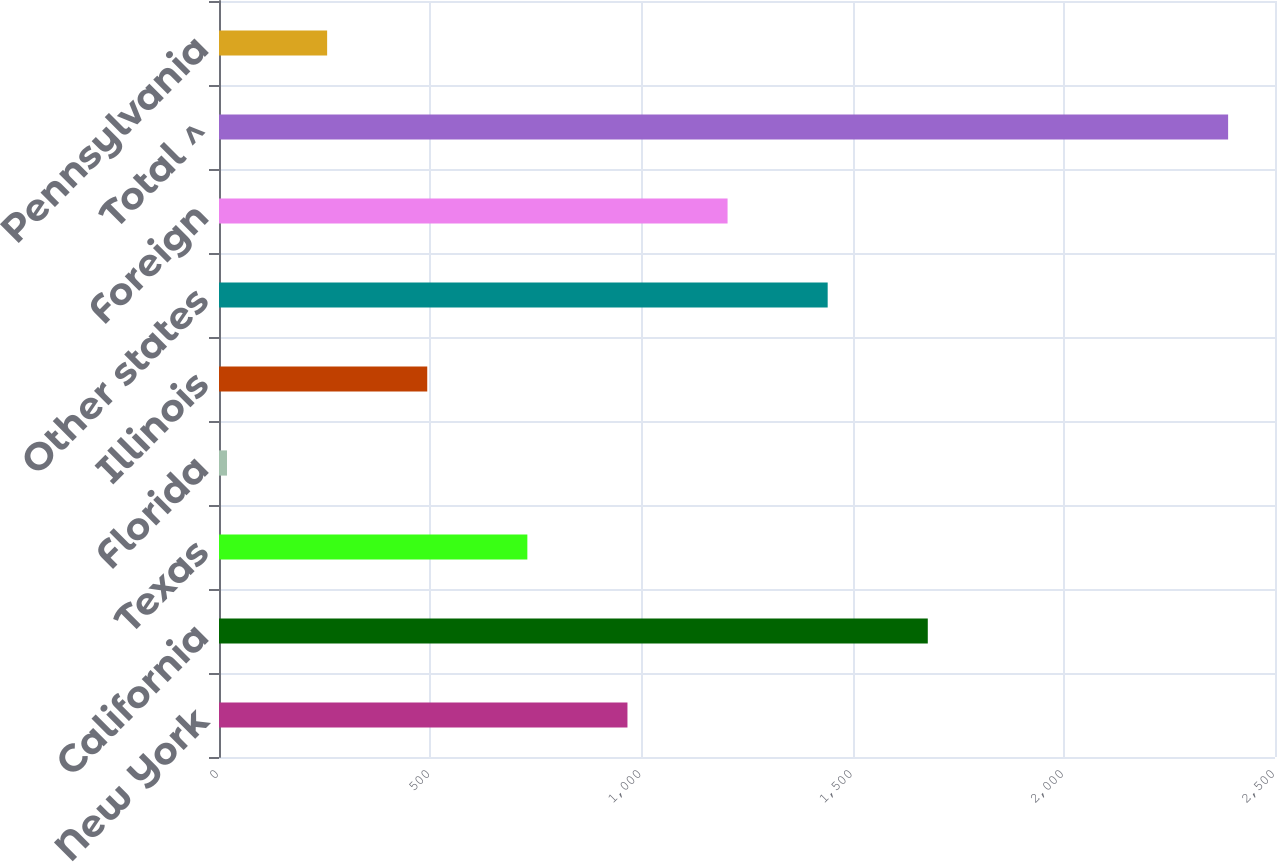Convert chart. <chart><loc_0><loc_0><loc_500><loc_500><bar_chart><fcel>New York<fcel>California<fcel>Texas<fcel>Florida<fcel>Illinois<fcel>Other states<fcel>Foreign<fcel>Total ^<fcel>Pennsylvania<nl><fcel>967<fcel>1678<fcel>730<fcel>19<fcel>493<fcel>1441<fcel>1204<fcel>2389<fcel>256<nl></chart> 